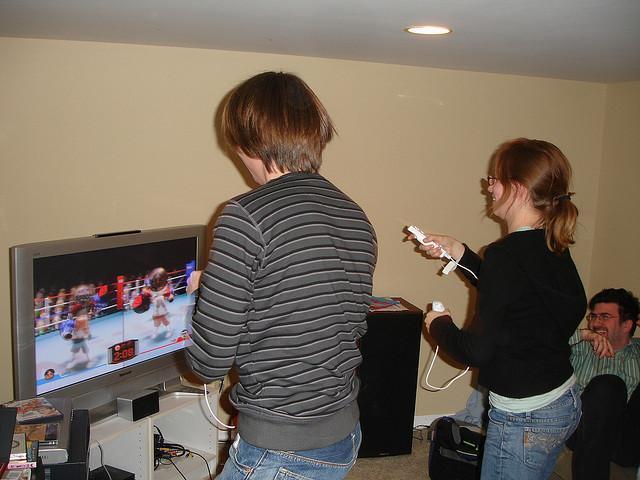What color shirt does the person opposing the wii woman in black?
Select the accurate response from the four choices given to answer the question.
Options: Striped gray, green stripe, black, none. Striped gray. 